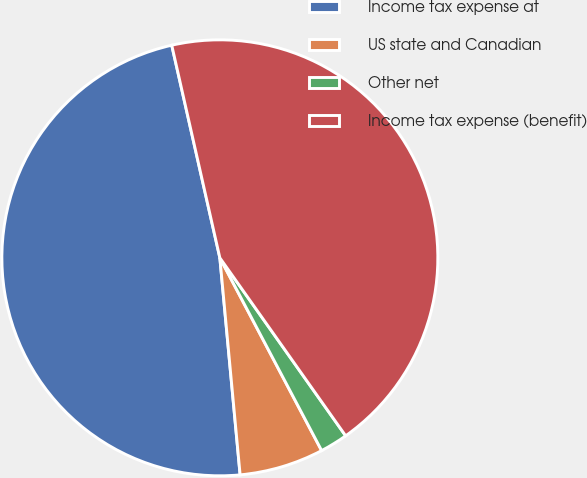Convert chart to OTSL. <chart><loc_0><loc_0><loc_500><loc_500><pie_chart><fcel>Income tax expense at<fcel>US state and Canadian<fcel>Other net<fcel>Income tax expense (benefit)<nl><fcel>47.94%<fcel>6.25%<fcel>2.06%<fcel>43.75%<nl></chart> 